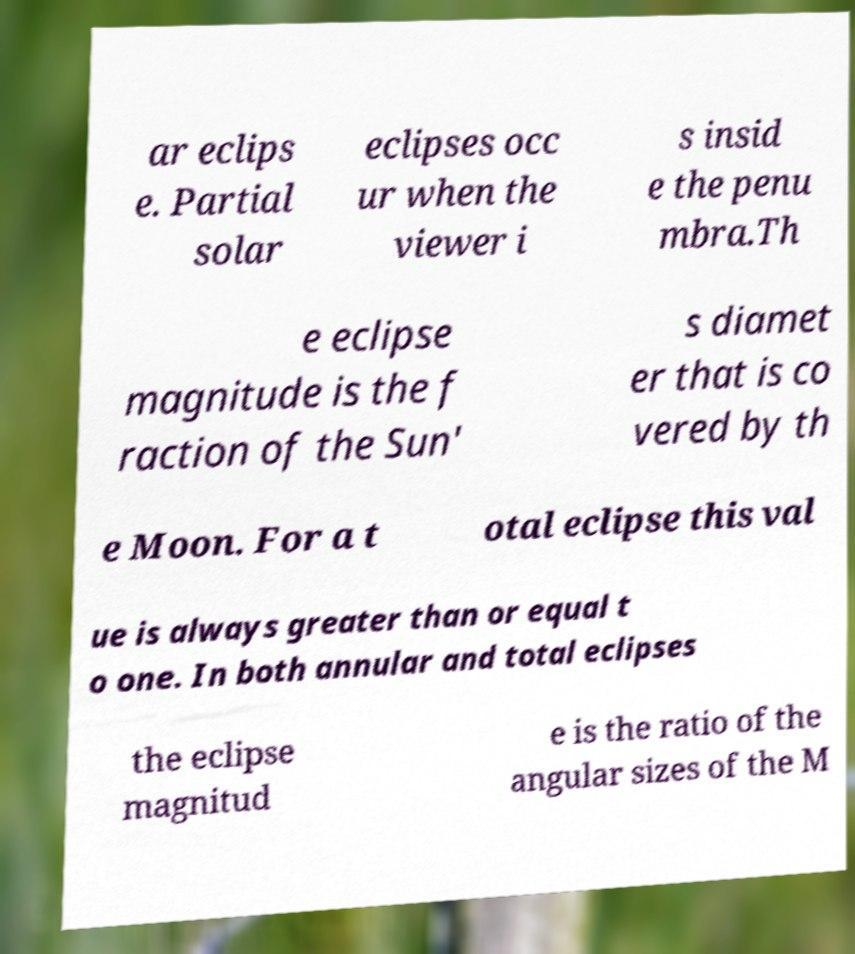Please identify and transcribe the text found in this image. ar eclips e. Partial solar eclipses occ ur when the viewer i s insid e the penu mbra.Th e eclipse magnitude is the f raction of the Sun' s diamet er that is co vered by th e Moon. For a t otal eclipse this val ue is always greater than or equal t o one. In both annular and total eclipses the eclipse magnitud e is the ratio of the angular sizes of the M 